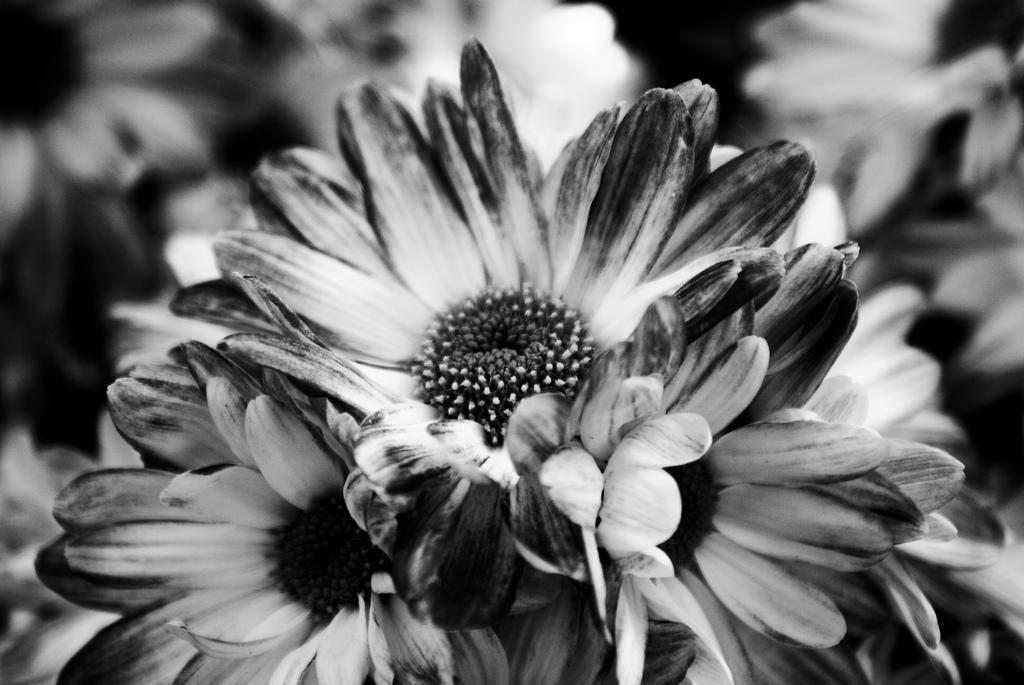Describe this image in one or two sentences. In this image we can see flowers. 